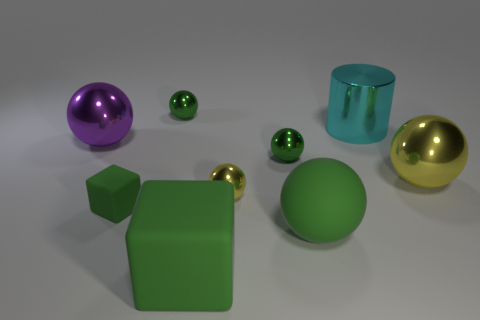Subtract all yellow spheres. How many were subtracted if there are1yellow spheres left? 1 Subtract all blue cubes. How many green spheres are left? 3 Subtract all purple balls. How many balls are left? 5 Subtract all large purple balls. How many balls are left? 5 Subtract all gray spheres. Subtract all cyan blocks. How many spheres are left? 6 Subtract all cubes. How many objects are left? 7 Add 6 large yellow metal objects. How many large yellow metal objects are left? 7 Add 1 metal objects. How many metal objects exist? 7 Subtract 0 cyan blocks. How many objects are left? 9 Subtract all big brown balls. Subtract all large yellow shiny objects. How many objects are left? 8 